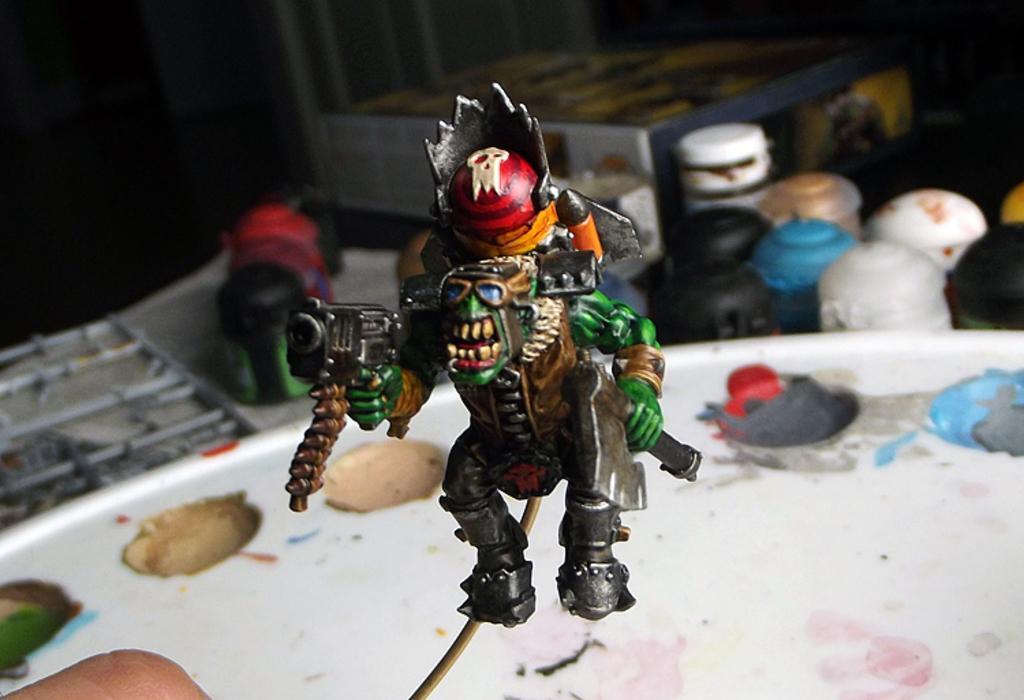Please provide a concise description of this image. In this picture we can see a toy, box, person hand and some objects and in the background it is dark. 